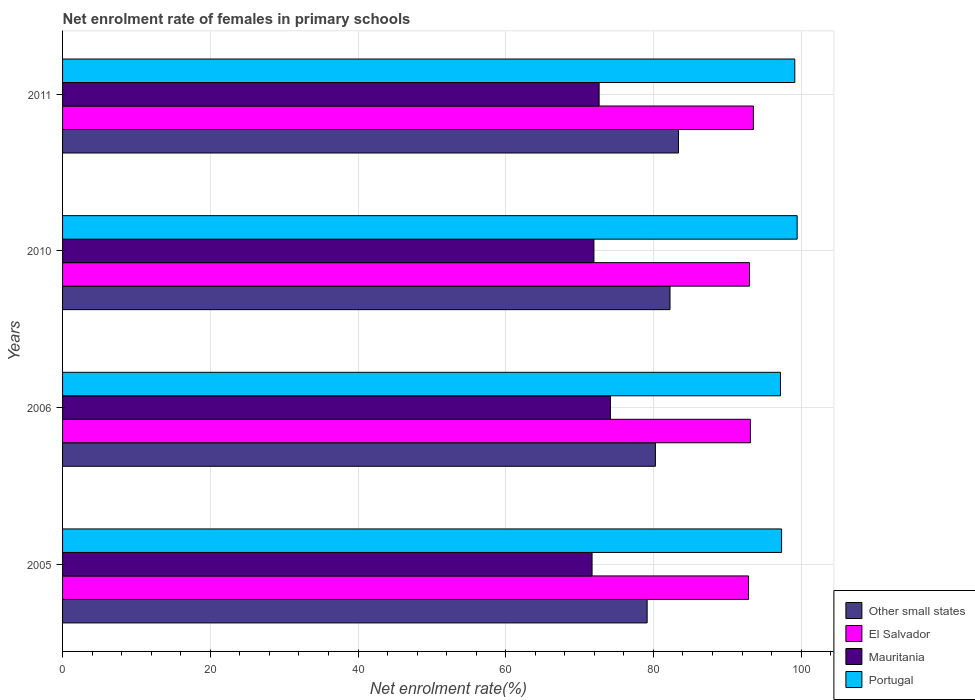How many different coloured bars are there?
Give a very brief answer. 4. Are the number of bars per tick equal to the number of legend labels?
Your response must be concise. Yes. How many bars are there on the 3rd tick from the top?
Make the answer very short. 4. How many bars are there on the 4th tick from the bottom?
Your response must be concise. 4. What is the label of the 2nd group of bars from the top?
Give a very brief answer. 2010. In how many cases, is the number of bars for a given year not equal to the number of legend labels?
Provide a short and direct response. 0. What is the net enrolment rate of females in primary schools in Other small states in 2006?
Give a very brief answer. 80.27. Across all years, what is the maximum net enrolment rate of females in primary schools in Other small states?
Your response must be concise. 83.39. Across all years, what is the minimum net enrolment rate of females in primary schools in Portugal?
Provide a short and direct response. 97.2. In which year was the net enrolment rate of females in primary schools in Mauritania minimum?
Make the answer very short. 2005. What is the total net enrolment rate of females in primary schools in Portugal in the graph?
Your response must be concise. 393.14. What is the difference between the net enrolment rate of females in primary schools in El Salvador in 2010 and that in 2011?
Offer a terse response. -0.52. What is the difference between the net enrolment rate of females in primary schools in Portugal in 2006 and the net enrolment rate of females in primary schools in Other small states in 2005?
Keep it short and to the point. 18.05. What is the average net enrolment rate of females in primary schools in Other small states per year?
Your response must be concise. 81.26. In the year 2010, what is the difference between the net enrolment rate of females in primary schools in Portugal and net enrolment rate of females in primary schools in Other small states?
Make the answer very short. 17.21. In how many years, is the net enrolment rate of females in primary schools in Other small states greater than 56 %?
Ensure brevity in your answer.  4. What is the ratio of the net enrolment rate of females in primary schools in Mauritania in 2005 to that in 2006?
Provide a short and direct response. 0.97. Is the net enrolment rate of females in primary schools in Other small states in 2006 less than that in 2010?
Provide a succinct answer. Yes. Is the difference between the net enrolment rate of females in primary schools in Portugal in 2006 and 2010 greater than the difference between the net enrolment rate of females in primary schools in Other small states in 2006 and 2010?
Offer a terse response. No. What is the difference between the highest and the second highest net enrolment rate of females in primary schools in Portugal?
Provide a short and direct response. 0.32. What is the difference between the highest and the lowest net enrolment rate of females in primary schools in Other small states?
Your answer should be very brief. 4.24. In how many years, is the net enrolment rate of females in primary schools in El Salvador greater than the average net enrolment rate of females in primary schools in El Salvador taken over all years?
Offer a very short reply. 1. Is the sum of the net enrolment rate of females in primary schools in Other small states in 2005 and 2006 greater than the maximum net enrolment rate of females in primary schools in Portugal across all years?
Offer a very short reply. Yes. Is it the case that in every year, the sum of the net enrolment rate of females in primary schools in Mauritania and net enrolment rate of females in primary schools in Portugal is greater than the sum of net enrolment rate of females in primary schools in El Salvador and net enrolment rate of females in primary schools in Other small states?
Offer a terse response. Yes. What does the 2nd bar from the bottom in 2011 represents?
Your answer should be very brief. El Salvador. Is it the case that in every year, the sum of the net enrolment rate of females in primary schools in El Salvador and net enrolment rate of females in primary schools in Portugal is greater than the net enrolment rate of females in primary schools in Mauritania?
Give a very brief answer. Yes. How many bars are there?
Offer a terse response. 16. What is the difference between two consecutive major ticks on the X-axis?
Ensure brevity in your answer.  20. Are the values on the major ticks of X-axis written in scientific E-notation?
Make the answer very short. No. Does the graph contain grids?
Keep it short and to the point. Yes. Where does the legend appear in the graph?
Ensure brevity in your answer.  Bottom right. How many legend labels are there?
Your answer should be very brief. 4. What is the title of the graph?
Your response must be concise. Net enrolment rate of females in primary schools. What is the label or title of the X-axis?
Your answer should be very brief. Net enrolment rate(%). What is the label or title of the Y-axis?
Offer a very short reply. Years. What is the Net enrolment rate(%) of Other small states in 2005?
Offer a very short reply. 79.15. What is the Net enrolment rate(%) in El Salvador in 2005?
Keep it short and to the point. 92.88. What is the Net enrolment rate(%) in Mauritania in 2005?
Provide a short and direct response. 71.69. What is the Net enrolment rate(%) of Portugal in 2005?
Your answer should be very brief. 97.35. What is the Net enrolment rate(%) of Other small states in 2006?
Your response must be concise. 80.27. What is the Net enrolment rate(%) of El Salvador in 2006?
Give a very brief answer. 93.13. What is the Net enrolment rate(%) of Mauritania in 2006?
Offer a terse response. 74.18. What is the Net enrolment rate(%) in Portugal in 2006?
Your response must be concise. 97.2. What is the Net enrolment rate(%) in Other small states in 2010?
Your answer should be compact. 82.24. What is the Net enrolment rate(%) in El Salvador in 2010?
Offer a terse response. 93.01. What is the Net enrolment rate(%) in Mauritania in 2010?
Offer a very short reply. 71.94. What is the Net enrolment rate(%) of Portugal in 2010?
Offer a very short reply. 99.46. What is the Net enrolment rate(%) of Other small states in 2011?
Your answer should be very brief. 83.39. What is the Net enrolment rate(%) of El Salvador in 2011?
Provide a short and direct response. 93.54. What is the Net enrolment rate(%) of Mauritania in 2011?
Your response must be concise. 72.65. What is the Net enrolment rate(%) of Portugal in 2011?
Keep it short and to the point. 99.14. Across all years, what is the maximum Net enrolment rate(%) in Other small states?
Your answer should be compact. 83.39. Across all years, what is the maximum Net enrolment rate(%) in El Salvador?
Offer a very short reply. 93.54. Across all years, what is the maximum Net enrolment rate(%) in Mauritania?
Your answer should be very brief. 74.18. Across all years, what is the maximum Net enrolment rate(%) of Portugal?
Keep it short and to the point. 99.46. Across all years, what is the minimum Net enrolment rate(%) in Other small states?
Make the answer very short. 79.15. Across all years, what is the minimum Net enrolment rate(%) in El Salvador?
Offer a very short reply. 92.88. Across all years, what is the minimum Net enrolment rate(%) of Mauritania?
Offer a terse response. 71.69. Across all years, what is the minimum Net enrolment rate(%) of Portugal?
Your answer should be very brief. 97.2. What is the total Net enrolment rate(%) of Other small states in the graph?
Provide a succinct answer. 325.04. What is the total Net enrolment rate(%) of El Salvador in the graph?
Provide a succinct answer. 372.55. What is the total Net enrolment rate(%) of Mauritania in the graph?
Offer a very short reply. 290.45. What is the total Net enrolment rate(%) in Portugal in the graph?
Offer a terse response. 393.14. What is the difference between the Net enrolment rate(%) in Other small states in 2005 and that in 2006?
Keep it short and to the point. -1.12. What is the difference between the Net enrolment rate(%) of El Salvador in 2005 and that in 2006?
Make the answer very short. -0.25. What is the difference between the Net enrolment rate(%) in Mauritania in 2005 and that in 2006?
Give a very brief answer. -2.49. What is the difference between the Net enrolment rate(%) in Portugal in 2005 and that in 2006?
Provide a short and direct response. 0.15. What is the difference between the Net enrolment rate(%) of Other small states in 2005 and that in 2010?
Offer a terse response. -3.1. What is the difference between the Net enrolment rate(%) of El Salvador in 2005 and that in 2010?
Your response must be concise. -0.13. What is the difference between the Net enrolment rate(%) in Mauritania in 2005 and that in 2010?
Keep it short and to the point. -0.25. What is the difference between the Net enrolment rate(%) of Portugal in 2005 and that in 2010?
Give a very brief answer. -2.11. What is the difference between the Net enrolment rate(%) in Other small states in 2005 and that in 2011?
Offer a very short reply. -4.24. What is the difference between the Net enrolment rate(%) in El Salvador in 2005 and that in 2011?
Your response must be concise. -0.66. What is the difference between the Net enrolment rate(%) in Mauritania in 2005 and that in 2011?
Offer a very short reply. -0.96. What is the difference between the Net enrolment rate(%) of Portugal in 2005 and that in 2011?
Keep it short and to the point. -1.79. What is the difference between the Net enrolment rate(%) in Other small states in 2006 and that in 2010?
Offer a very short reply. -1.98. What is the difference between the Net enrolment rate(%) of El Salvador in 2006 and that in 2010?
Offer a terse response. 0.12. What is the difference between the Net enrolment rate(%) in Mauritania in 2006 and that in 2010?
Your answer should be compact. 2.23. What is the difference between the Net enrolment rate(%) of Portugal in 2006 and that in 2010?
Your response must be concise. -2.26. What is the difference between the Net enrolment rate(%) of Other small states in 2006 and that in 2011?
Offer a terse response. -3.12. What is the difference between the Net enrolment rate(%) of El Salvador in 2006 and that in 2011?
Keep it short and to the point. -0.41. What is the difference between the Net enrolment rate(%) in Mauritania in 2006 and that in 2011?
Your answer should be compact. 1.53. What is the difference between the Net enrolment rate(%) in Portugal in 2006 and that in 2011?
Keep it short and to the point. -1.94. What is the difference between the Net enrolment rate(%) in Other small states in 2010 and that in 2011?
Keep it short and to the point. -1.14. What is the difference between the Net enrolment rate(%) in El Salvador in 2010 and that in 2011?
Your response must be concise. -0.52. What is the difference between the Net enrolment rate(%) of Mauritania in 2010 and that in 2011?
Offer a terse response. -0.7. What is the difference between the Net enrolment rate(%) in Portugal in 2010 and that in 2011?
Keep it short and to the point. 0.32. What is the difference between the Net enrolment rate(%) in Other small states in 2005 and the Net enrolment rate(%) in El Salvador in 2006?
Your answer should be compact. -13.98. What is the difference between the Net enrolment rate(%) in Other small states in 2005 and the Net enrolment rate(%) in Mauritania in 2006?
Offer a terse response. 4.97. What is the difference between the Net enrolment rate(%) of Other small states in 2005 and the Net enrolment rate(%) of Portugal in 2006?
Offer a very short reply. -18.05. What is the difference between the Net enrolment rate(%) in El Salvador in 2005 and the Net enrolment rate(%) in Mauritania in 2006?
Give a very brief answer. 18.7. What is the difference between the Net enrolment rate(%) of El Salvador in 2005 and the Net enrolment rate(%) of Portugal in 2006?
Your response must be concise. -4.32. What is the difference between the Net enrolment rate(%) of Mauritania in 2005 and the Net enrolment rate(%) of Portugal in 2006?
Make the answer very short. -25.51. What is the difference between the Net enrolment rate(%) of Other small states in 2005 and the Net enrolment rate(%) of El Salvador in 2010?
Keep it short and to the point. -13.87. What is the difference between the Net enrolment rate(%) in Other small states in 2005 and the Net enrolment rate(%) in Mauritania in 2010?
Offer a very short reply. 7.2. What is the difference between the Net enrolment rate(%) in Other small states in 2005 and the Net enrolment rate(%) in Portugal in 2010?
Offer a very short reply. -20.31. What is the difference between the Net enrolment rate(%) in El Salvador in 2005 and the Net enrolment rate(%) in Mauritania in 2010?
Your answer should be compact. 20.93. What is the difference between the Net enrolment rate(%) in El Salvador in 2005 and the Net enrolment rate(%) in Portugal in 2010?
Keep it short and to the point. -6.58. What is the difference between the Net enrolment rate(%) of Mauritania in 2005 and the Net enrolment rate(%) of Portugal in 2010?
Your answer should be very brief. -27.77. What is the difference between the Net enrolment rate(%) of Other small states in 2005 and the Net enrolment rate(%) of El Salvador in 2011?
Give a very brief answer. -14.39. What is the difference between the Net enrolment rate(%) of Other small states in 2005 and the Net enrolment rate(%) of Mauritania in 2011?
Offer a very short reply. 6.5. What is the difference between the Net enrolment rate(%) of Other small states in 2005 and the Net enrolment rate(%) of Portugal in 2011?
Keep it short and to the point. -19.99. What is the difference between the Net enrolment rate(%) in El Salvador in 2005 and the Net enrolment rate(%) in Mauritania in 2011?
Offer a very short reply. 20.23. What is the difference between the Net enrolment rate(%) in El Salvador in 2005 and the Net enrolment rate(%) in Portugal in 2011?
Give a very brief answer. -6.26. What is the difference between the Net enrolment rate(%) in Mauritania in 2005 and the Net enrolment rate(%) in Portugal in 2011?
Make the answer very short. -27.45. What is the difference between the Net enrolment rate(%) of Other small states in 2006 and the Net enrolment rate(%) of El Salvador in 2010?
Your response must be concise. -12.75. What is the difference between the Net enrolment rate(%) of Other small states in 2006 and the Net enrolment rate(%) of Mauritania in 2010?
Give a very brief answer. 8.32. What is the difference between the Net enrolment rate(%) of Other small states in 2006 and the Net enrolment rate(%) of Portugal in 2010?
Your response must be concise. -19.19. What is the difference between the Net enrolment rate(%) of El Salvador in 2006 and the Net enrolment rate(%) of Mauritania in 2010?
Provide a short and direct response. 21.18. What is the difference between the Net enrolment rate(%) of El Salvador in 2006 and the Net enrolment rate(%) of Portugal in 2010?
Offer a terse response. -6.33. What is the difference between the Net enrolment rate(%) of Mauritania in 2006 and the Net enrolment rate(%) of Portugal in 2010?
Your answer should be very brief. -25.28. What is the difference between the Net enrolment rate(%) in Other small states in 2006 and the Net enrolment rate(%) in El Salvador in 2011?
Make the answer very short. -13.27. What is the difference between the Net enrolment rate(%) in Other small states in 2006 and the Net enrolment rate(%) in Mauritania in 2011?
Ensure brevity in your answer.  7.62. What is the difference between the Net enrolment rate(%) of Other small states in 2006 and the Net enrolment rate(%) of Portugal in 2011?
Provide a short and direct response. -18.87. What is the difference between the Net enrolment rate(%) of El Salvador in 2006 and the Net enrolment rate(%) of Mauritania in 2011?
Offer a terse response. 20.48. What is the difference between the Net enrolment rate(%) in El Salvador in 2006 and the Net enrolment rate(%) in Portugal in 2011?
Provide a succinct answer. -6.01. What is the difference between the Net enrolment rate(%) in Mauritania in 2006 and the Net enrolment rate(%) in Portugal in 2011?
Your answer should be very brief. -24.96. What is the difference between the Net enrolment rate(%) of Other small states in 2010 and the Net enrolment rate(%) of El Salvador in 2011?
Give a very brief answer. -11.29. What is the difference between the Net enrolment rate(%) in Other small states in 2010 and the Net enrolment rate(%) in Mauritania in 2011?
Offer a terse response. 9.6. What is the difference between the Net enrolment rate(%) of Other small states in 2010 and the Net enrolment rate(%) of Portugal in 2011?
Your response must be concise. -16.89. What is the difference between the Net enrolment rate(%) in El Salvador in 2010 and the Net enrolment rate(%) in Mauritania in 2011?
Your answer should be compact. 20.36. What is the difference between the Net enrolment rate(%) in El Salvador in 2010 and the Net enrolment rate(%) in Portugal in 2011?
Provide a succinct answer. -6.12. What is the difference between the Net enrolment rate(%) in Mauritania in 2010 and the Net enrolment rate(%) in Portugal in 2011?
Keep it short and to the point. -27.19. What is the average Net enrolment rate(%) of Other small states per year?
Provide a succinct answer. 81.26. What is the average Net enrolment rate(%) in El Salvador per year?
Provide a short and direct response. 93.14. What is the average Net enrolment rate(%) in Mauritania per year?
Your answer should be compact. 72.61. What is the average Net enrolment rate(%) of Portugal per year?
Keep it short and to the point. 98.29. In the year 2005, what is the difference between the Net enrolment rate(%) in Other small states and Net enrolment rate(%) in El Salvador?
Your answer should be compact. -13.73. In the year 2005, what is the difference between the Net enrolment rate(%) in Other small states and Net enrolment rate(%) in Mauritania?
Keep it short and to the point. 7.46. In the year 2005, what is the difference between the Net enrolment rate(%) of Other small states and Net enrolment rate(%) of Portugal?
Keep it short and to the point. -18.2. In the year 2005, what is the difference between the Net enrolment rate(%) in El Salvador and Net enrolment rate(%) in Mauritania?
Provide a succinct answer. 21.19. In the year 2005, what is the difference between the Net enrolment rate(%) in El Salvador and Net enrolment rate(%) in Portugal?
Make the answer very short. -4.47. In the year 2005, what is the difference between the Net enrolment rate(%) of Mauritania and Net enrolment rate(%) of Portugal?
Your answer should be very brief. -25.66. In the year 2006, what is the difference between the Net enrolment rate(%) in Other small states and Net enrolment rate(%) in El Salvador?
Give a very brief answer. -12.86. In the year 2006, what is the difference between the Net enrolment rate(%) in Other small states and Net enrolment rate(%) in Mauritania?
Your answer should be very brief. 6.09. In the year 2006, what is the difference between the Net enrolment rate(%) of Other small states and Net enrolment rate(%) of Portugal?
Ensure brevity in your answer.  -16.93. In the year 2006, what is the difference between the Net enrolment rate(%) of El Salvador and Net enrolment rate(%) of Mauritania?
Your answer should be compact. 18.95. In the year 2006, what is the difference between the Net enrolment rate(%) in El Salvador and Net enrolment rate(%) in Portugal?
Ensure brevity in your answer.  -4.07. In the year 2006, what is the difference between the Net enrolment rate(%) of Mauritania and Net enrolment rate(%) of Portugal?
Keep it short and to the point. -23.02. In the year 2010, what is the difference between the Net enrolment rate(%) of Other small states and Net enrolment rate(%) of El Salvador?
Your answer should be compact. -10.77. In the year 2010, what is the difference between the Net enrolment rate(%) in Other small states and Net enrolment rate(%) in Mauritania?
Ensure brevity in your answer.  10.3. In the year 2010, what is the difference between the Net enrolment rate(%) in Other small states and Net enrolment rate(%) in Portugal?
Your answer should be compact. -17.21. In the year 2010, what is the difference between the Net enrolment rate(%) of El Salvador and Net enrolment rate(%) of Mauritania?
Provide a succinct answer. 21.07. In the year 2010, what is the difference between the Net enrolment rate(%) of El Salvador and Net enrolment rate(%) of Portugal?
Ensure brevity in your answer.  -6.45. In the year 2010, what is the difference between the Net enrolment rate(%) of Mauritania and Net enrolment rate(%) of Portugal?
Make the answer very short. -27.51. In the year 2011, what is the difference between the Net enrolment rate(%) in Other small states and Net enrolment rate(%) in El Salvador?
Ensure brevity in your answer.  -10.15. In the year 2011, what is the difference between the Net enrolment rate(%) in Other small states and Net enrolment rate(%) in Mauritania?
Your answer should be compact. 10.74. In the year 2011, what is the difference between the Net enrolment rate(%) of Other small states and Net enrolment rate(%) of Portugal?
Keep it short and to the point. -15.75. In the year 2011, what is the difference between the Net enrolment rate(%) in El Salvador and Net enrolment rate(%) in Mauritania?
Make the answer very short. 20.89. In the year 2011, what is the difference between the Net enrolment rate(%) in El Salvador and Net enrolment rate(%) in Portugal?
Provide a short and direct response. -5.6. In the year 2011, what is the difference between the Net enrolment rate(%) of Mauritania and Net enrolment rate(%) of Portugal?
Make the answer very short. -26.49. What is the ratio of the Net enrolment rate(%) in Other small states in 2005 to that in 2006?
Your answer should be very brief. 0.99. What is the ratio of the Net enrolment rate(%) of Mauritania in 2005 to that in 2006?
Provide a short and direct response. 0.97. What is the ratio of the Net enrolment rate(%) of Portugal in 2005 to that in 2006?
Your answer should be compact. 1. What is the ratio of the Net enrolment rate(%) in Other small states in 2005 to that in 2010?
Keep it short and to the point. 0.96. What is the ratio of the Net enrolment rate(%) in El Salvador in 2005 to that in 2010?
Give a very brief answer. 1. What is the ratio of the Net enrolment rate(%) of Mauritania in 2005 to that in 2010?
Offer a terse response. 1. What is the ratio of the Net enrolment rate(%) of Portugal in 2005 to that in 2010?
Your response must be concise. 0.98. What is the ratio of the Net enrolment rate(%) in Other small states in 2005 to that in 2011?
Provide a short and direct response. 0.95. What is the ratio of the Net enrolment rate(%) of El Salvador in 2005 to that in 2011?
Offer a terse response. 0.99. What is the ratio of the Net enrolment rate(%) of Mauritania in 2005 to that in 2011?
Ensure brevity in your answer.  0.99. What is the ratio of the Net enrolment rate(%) in Other small states in 2006 to that in 2010?
Provide a succinct answer. 0.98. What is the ratio of the Net enrolment rate(%) in El Salvador in 2006 to that in 2010?
Provide a succinct answer. 1. What is the ratio of the Net enrolment rate(%) in Mauritania in 2006 to that in 2010?
Your answer should be very brief. 1.03. What is the ratio of the Net enrolment rate(%) in Portugal in 2006 to that in 2010?
Provide a short and direct response. 0.98. What is the ratio of the Net enrolment rate(%) of Other small states in 2006 to that in 2011?
Your answer should be very brief. 0.96. What is the ratio of the Net enrolment rate(%) of El Salvador in 2006 to that in 2011?
Give a very brief answer. 1. What is the ratio of the Net enrolment rate(%) in Mauritania in 2006 to that in 2011?
Provide a succinct answer. 1.02. What is the ratio of the Net enrolment rate(%) of Portugal in 2006 to that in 2011?
Offer a terse response. 0.98. What is the ratio of the Net enrolment rate(%) of Other small states in 2010 to that in 2011?
Provide a succinct answer. 0.99. What is the ratio of the Net enrolment rate(%) of El Salvador in 2010 to that in 2011?
Your response must be concise. 0.99. What is the ratio of the Net enrolment rate(%) in Mauritania in 2010 to that in 2011?
Offer a very short reply. 0.99. What is the difference between the highest and the second highest Net enrolment rate(%) in Other small states?
Provide a short and direct response. 1.14. What is the difference between the highest and the second highest Net enrolment rate(%) of El Salvador?
Provide a short and direct response. 0.41. What is the difference between the highest and the second highest Net enrolment rate(%) of Mauritania?
Offer a very short reply. 1.53. What is the difference between the highest and the second highest Net enrolment rate(%) of Portugal?
Offer a very short reply. 0.32. What is the difference between the highest and the lowest Net enrolment rate(%) in Other small states?
Ensure brevity in your answer.  4.24. What is the difference between the highest and the lowest Net enrolment rate(%) of El Salvador?
Provide a succinct answer. 0.66. What is the difference between the highest and the lowest Net enrolment rate(%) of Mauritania?
Keep it short and to the point. 2.49. What is the difference between the highest and the lowest Net enrolment rate(%) of Portugal?
Offer a very short reply. 2.26. 